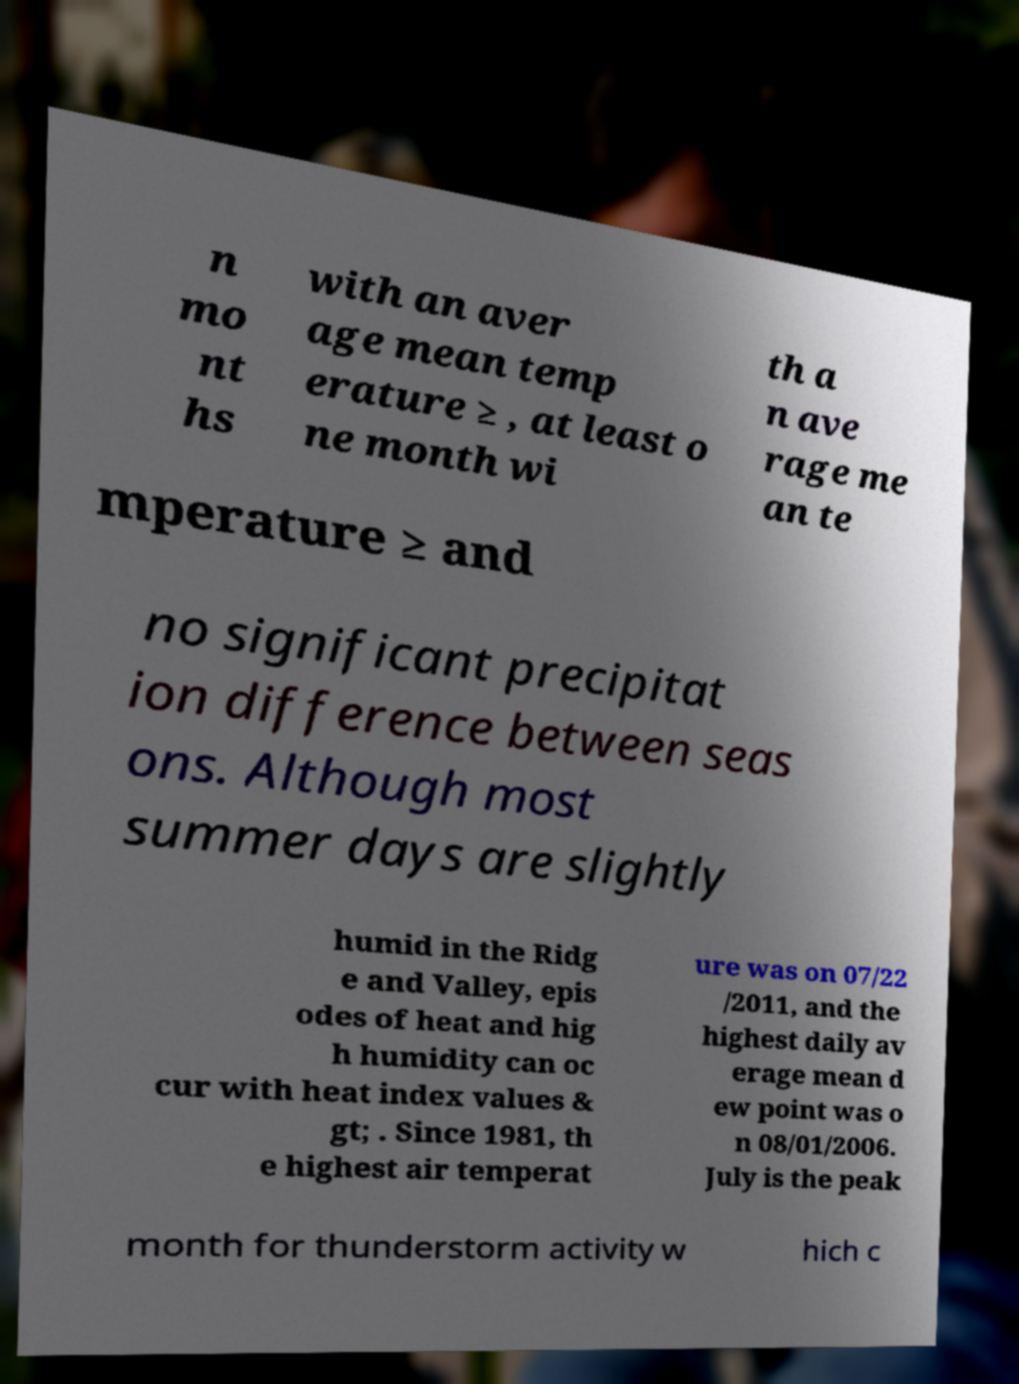Could you extract and type out the text from this image? n mo nt hs with an aver age mean temp erature ≥ , at least o ne month wi th a n ave rage me an te mperature ≥ and no significant precipitat ion difference between seas ons. Although most summer days are slightly humid in the Ridg e and Valley, epis odes of heat and hig h humidity can oc cur with heat index values & gt; . Since 1981, th e highest air temperat ure was on 07/22 /2011, and the highest daily av erage mean d ew point was o n 08/01/2006. July is the peak month for thunderstorm activity w hich c 